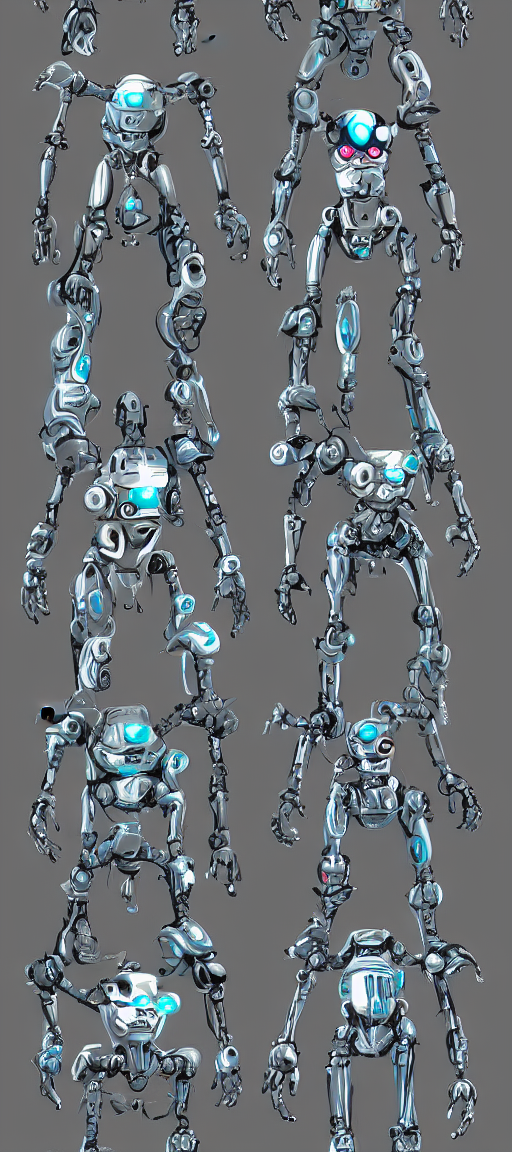What can be said about the colors in this image?
A. Mono-toned
B. Dull
C. Colorless
D. Rich
Answer with the option's letter from the given choices directly.
 D. 